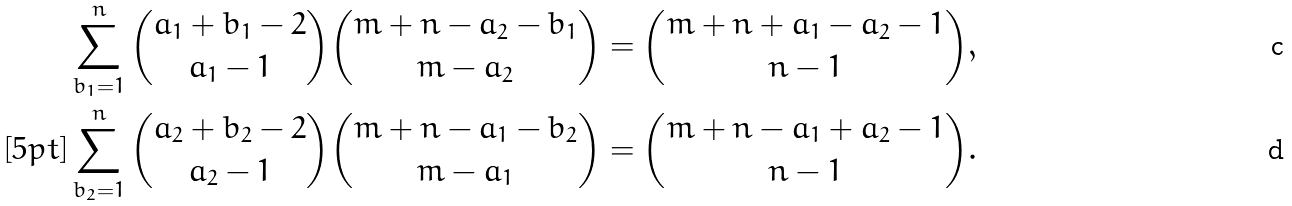<formula> <loc_0><loc_0><loc_500><loc_500>\sum _ { b _ { 1 } = 1 } ^ { n } { a _ { 1 } + b _ { 1 } - 2 \choose a _ { 1 } - 1 } { m + n - a _ { 2 } - b _ { 1 } \choose m - a _ { 2 } } & = { m + n + a _ { 1 } - a _ { 2 } - 1 \choose n - 1 } , \\ [ 5 p t ] \sum _ { b _ { 2 } = 1 } ^ { n } { a _ { 2 } + b _ { 2 } - 2 \choose a _ { 2 } - 1 } { m + n - a _ { 1 } - b _ { 2 } \choose m - a _ { 1 } } & = { m + n - a _ { 1 } + a _ { 2 } - 1 \choose n - 1 } .</formula> 